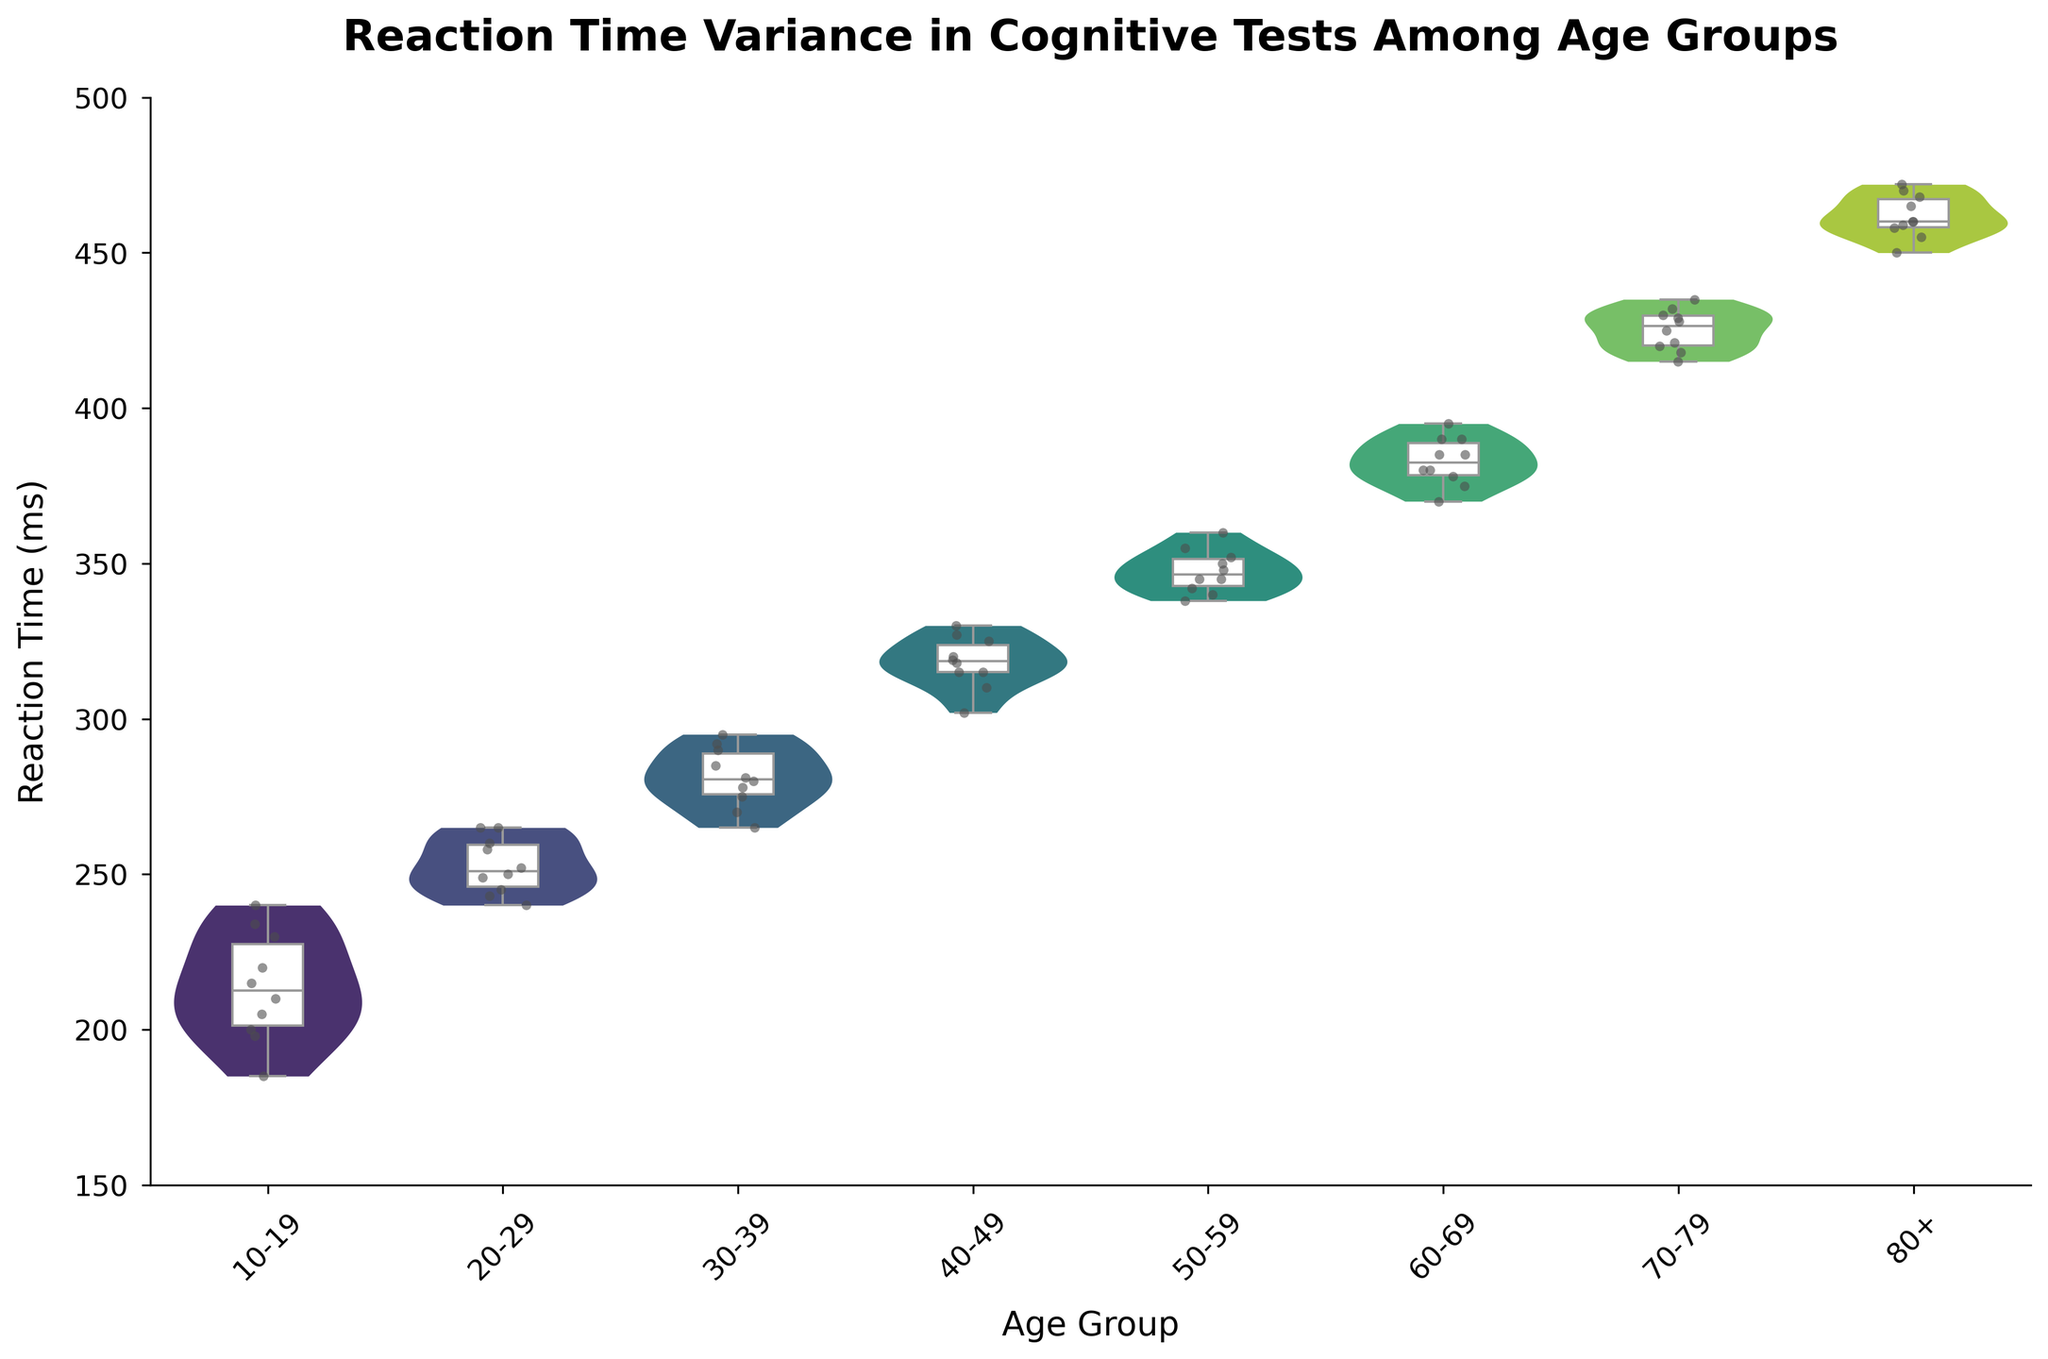What is the title of the figure? The title is prominently displayed at the top of the figure. It reads 'Reaction Time Variance in Cognitive Tests Among Age Groups'.
Answer: Reaction Time Variance in Cognitive Tests Among Age Groups Which age group shows the highest spread of reaction times? By observing the width of the violin plots, the age group 70-79 shows the highest spread, indicating the widest distribution of reaction times.
Answer: 70-79 What is the median reaction time for the 30-39 age group? The median value is represented by the line inside the box of the box plot. For the 30-39 age group, it is around 281 ms.
Answer: 281 ms Are there any age groups with an outlier in reaction times? Outliers would be represented as points outside the whiskers of the box plot. There are no visible outliers for any age group, indicating a compact distribution within whiskers.
Answer: No How do the reaction times for the 10-19 age group compare to the 50-59 age group? By observing both the violin and box plots, the 50-59 age group has generally higher reaction times compared to the 10-19 age group. The median for 50-59 is around 348 ms, while for 10-19, it is around 210 ms.
Answer: 50-59 has higher reaction times What are the lower and upper quartiles of the 40-49 age group? The lower quartile is the bottom line of the box, and the upper quartile is the top line of the box. For the 40-49 age group, the lower quartile is around 315 ms, and the upper quartile is around 320 ms.
Answer: 315 ms, 320 ms Which age group has the least variance in reaction times? The least variance is indicated by the narrowest width in the violin plot. The age group 10-19 shows the least variance.
Answer: 10-19 What is the interquartile range (IQR) for the 60-69 age group? The IQR is calculated as the difference between the upper quartile and lower quartile. For the 60-69 age group, the upper quartile is around 385 ms, and the lower quartile is around 378 ms, making the IQR 7 ms.
Answer: 7 ms Do older age groups generally have higher reaction times than younger age groups? By observing the plots from left to right (younger to older), there is a clear trend of increasing median reaction times in older age groups.
Answer: Yes 